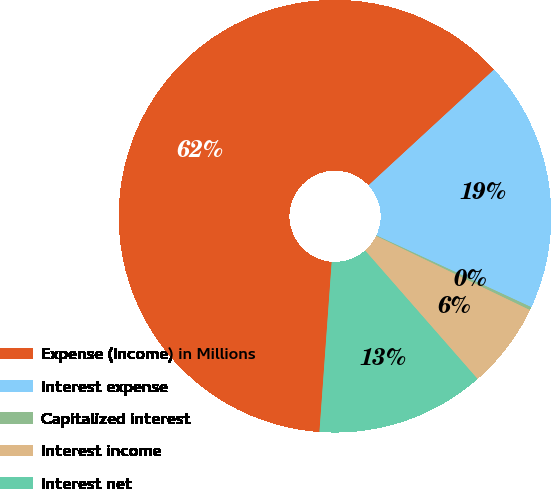<chart> <loc_0><loc_0><loc_500><loc_500><pie_chart><fcel>Expense (Income) in Millions<fcel>Interest expense<fcel>Capitalized interest<fcel>Interest income<fcel>Interest net<nl><fcel>62.0%<fcel>18.76%<fcel>0.24%<fcel>6.41%<fcel>12.59%<nl></chart> 